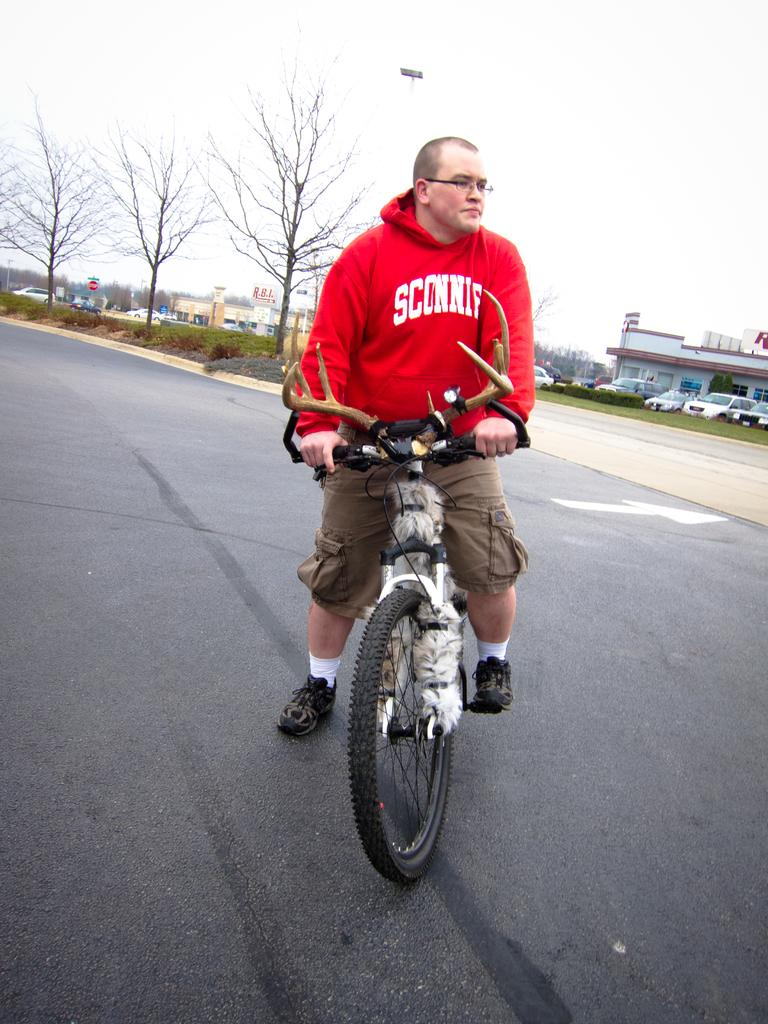What is the man in the image doing? The man is riding a bicycle. Where is the man riding the bicycle? The bicycle is on the road. What can be seen in the background of the image? There is a building, cars, and trees in the background of the image. What activity is the man doing while taking notes in the image? There is no mention of the man taking notes or any activity related to note-taking in the image. 